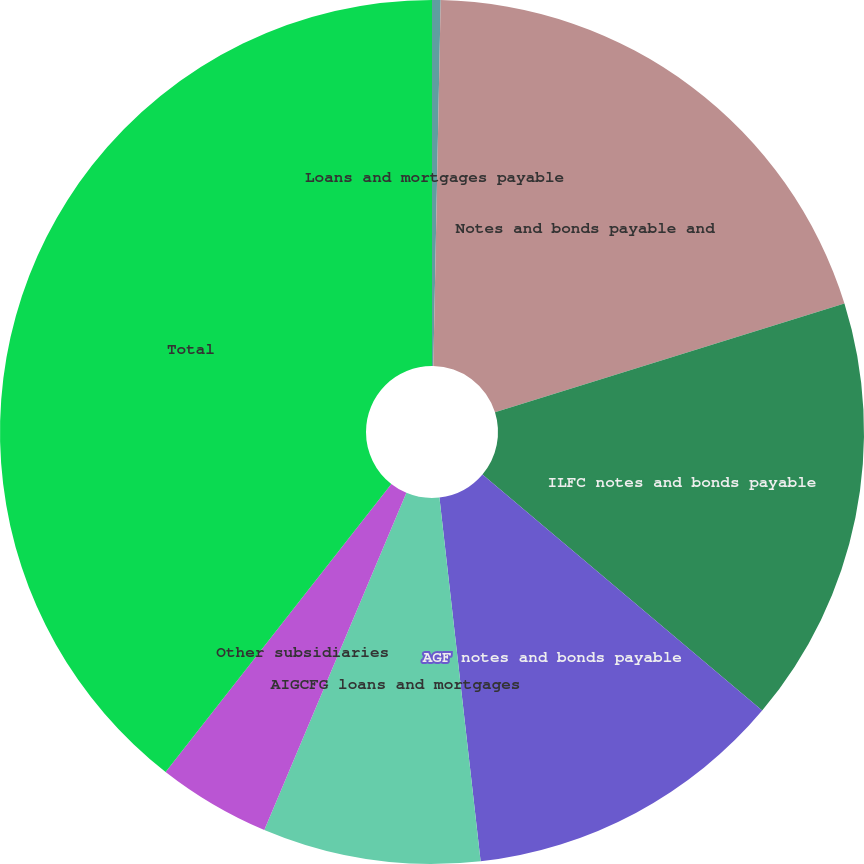<chart> <loc_0><loc_0><loc_500><loc_500><pie_chart><fcel>Loans and mortgages payable<fcel>Notes and bonds payable and<fcel>ILFC notes and bonds payable<fcel>AGF notes and bonds payable<fcel>AIGCFG loans and mortgages<fcel>Other subsidiaries<fcel>Total<nl><fcel>0.32%<fcel>19.87%<fcel>15.96%<fcel>12.05%<fcel>8.14%<fcel>4.23%<fcel>39.42%<nl></chart> 